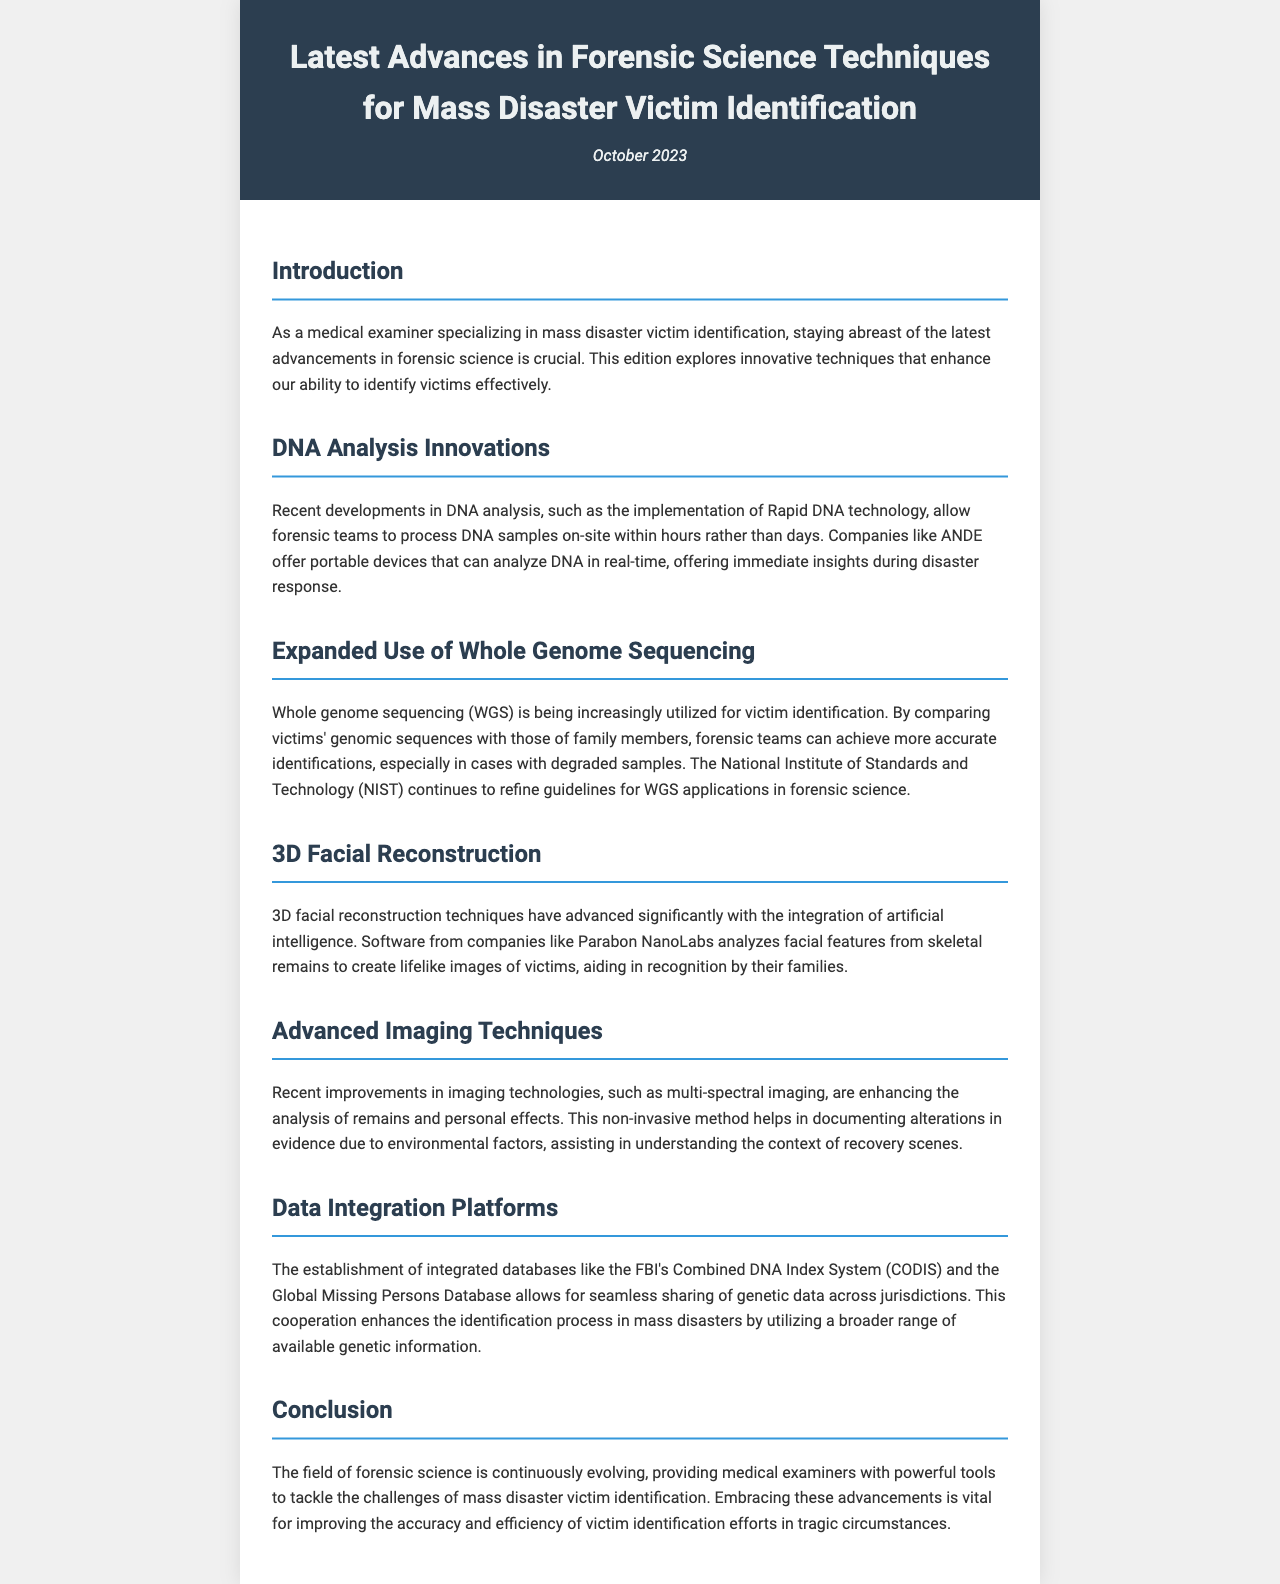What is the title of the newsletter? The title is clearly stated at the top of the document, which is "Latest Advances in Forensic Science Techniques for Mass Disaster Victim Identification."
Answer: Latest Advances in Forensic Science Techniques for Mass Disaster Victim Identification When was the newsletter published? The publication date is mentioned under the title, which indicates the month and year of release.
Answer: October 2023 What technology allows forensic teams to process DNA samples on-site? The document specifically highlights the innovative technology that enables real-time DNA processing in the field.
Answer: Rapid DNA technology Which organization is refining guidelines for Whole Genome Sequencing applications? The document notes a specific institution focused on enhancing practices around genomic sequencing in forensics.
Answer: National Institute of Standards and Technology (NIST) What is the purpose of 3D facial reconstruction techniques mentioned in the newsletter? The newsletter describes how these techniques are used in a specific context related to victim identification.
Answer: Aid in recognition by their families What type of imaging technique is highlighted for documenting evidence alterations? The newsletter discusses a particular non-invasive imaging method for analyzing remains and personal effects.
Answer: Multi-spectral imaging What does the FBI's Combined DNA Index System (CODIS) primarily support? The document explains the function of this database in the context of mass disaster victim identification.
Answer: Seamless sharing of genetic data What advancement utilizes artificial intelligence according to the document? The newsletter points out the integration of AI in a specific forensic technique related to victim identification.
Answer: 3D facial reconstruction 